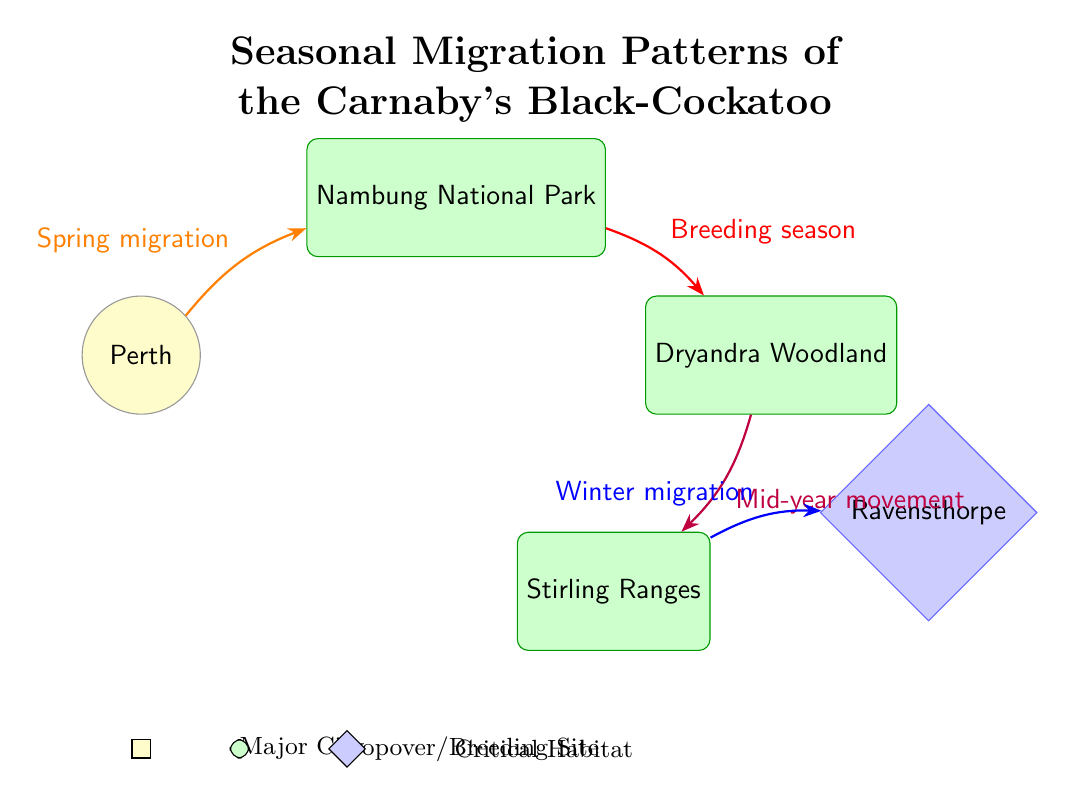What major city is the starting point for the seasonal migration? The diagram clearly marks Perth as a city, and the migration routes originate from this node.
Answer: Perth Which site is designated for the breeding season? The route labeled "Breeding season" leads from Nambung National Park to Dryandra Woodland, indicating that Dryandra is the breeding site.
Answer: Dryandra Woodland How many total stopover/breeding sites are indicated on the diagram? There are three distinct sites represented by green-shaped nodes: Nambung National Park, Dryandra Woodland, and Stirling Ranges. Counting these gives a total of three sites.
Answer: 3 What route is taken during winter migration? The diagram shows that the Winter migration route leads from the Stirling Ranges to Ravensthorpe, which can be identified from the colored line connected to the respective locations.
Answer: Stirling Ranges to Ravensthorpe Which migration route occurs in spring? The route marked with the label "Spring migration" connects Perth and Nambung, explicitly identifying it as the spring migration pathway.
Answer: Perth to Nambung Which site is the critical habitat? The diagram features Ravensthorpe as a critical habitat, denoted by its diamond shape and blue color, making it easy to distinguish from the other sites.
Answer: Ravensthorpe What color represents the major city in the diagram? The major city is represented in yellow, which is visible on the diagram next to the city node of Perth.
Answer: Yellow Which two sites are connected by the mid-year movement? The diagram shows a purple route identified as "Mid-year movement" that connects Dryandra Woodland to Stirling Ranges, confirming that these two sites are connected through this migration.
Answer: Dryandra Woodland to Stirling Ranges What is the significance of the arrows in this diagram? The arrows indicate the direction of migration and seasonal movements between the different locations, making it clear which way the Carnaby's Black-Cockatoo migrates throughout the seasons.
Answer: Direction of migration 